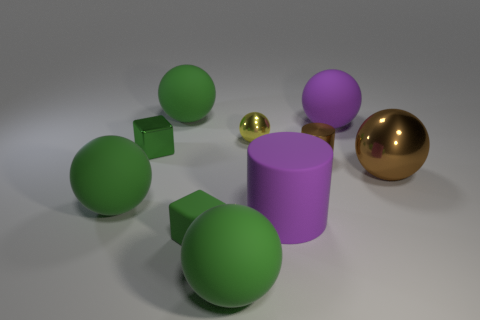The matte sphere to the left of the big green ball that is behind the tiny metallic cube that is to the left of the yellow metallic ball is what color?
Give a very brief answer. Green. What shape is the large thing that is right of the large rubber ball right of the yellow metallic sphere?
Offer a terse response. Sphere. Are there more tiny brown things right of the big brown object than tiny yellow cylinders?
Your answer should be compact. No. There is a brown thing behind the brown metallic ball; is it the same shape as the green metallic thing?
Offer a terse response. No. Is there a large brown thing that has the same shape as the yellow thing?
Offer a terse response. Yes. How many objects are big rubber things that are in front of the tiny brown object or red metallic spheres?
Your answer should be very brief. 3. Are there more small yellow matte objects than shiny blocks?
Make the answer very short. No. Is there a shiny block of the same size as the yellow metallic sphere?
Provide a short and direct response. Yes. How many things are large rubber balls that are behind the big purple matte ball or large objects that are in front of the small yellow object?
Your answer should be compact. 5. What color is the rubber sphere to the right of the green rubber ball in front of the small matte cube?
Provide a succinct answer. Purple. 